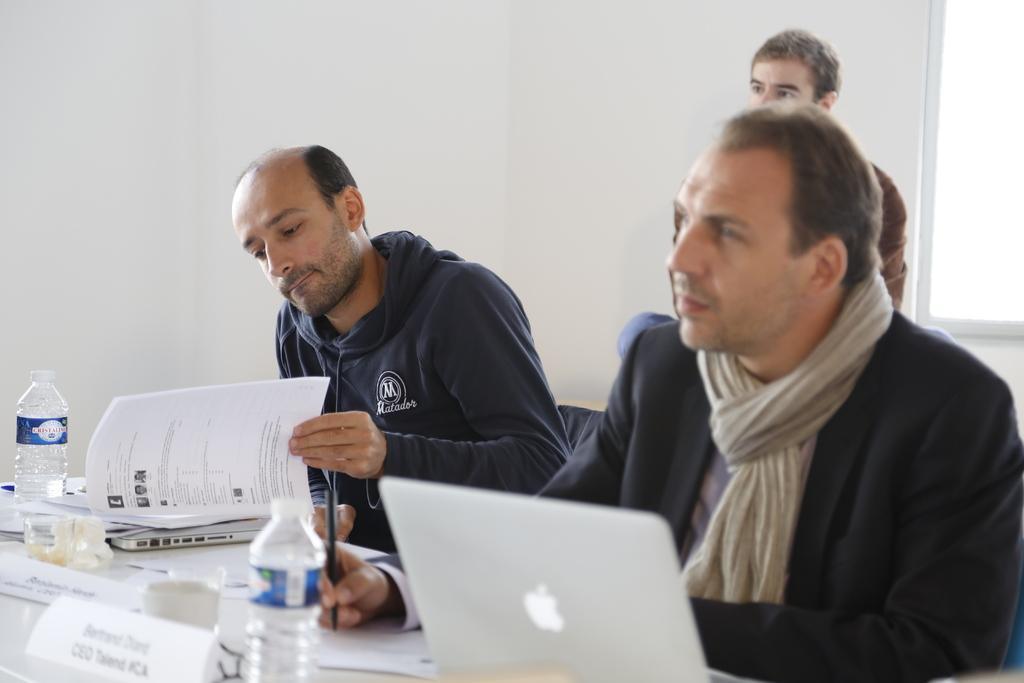Please provide a concise description of this image. In this picture there are three men sitting and we can see bottles, laptops, papers and objects on the table. In the background of the image we can see wall and window. 